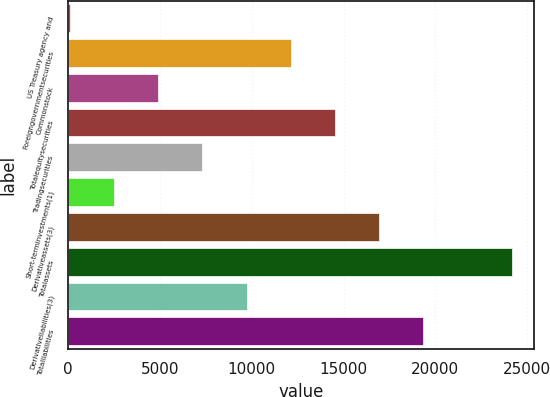Convert chart to OTSL. <chart><loc_0><loc_0><loc_500><loc_500><bar_chart><fcel>US Treasury agency and<fcel>Foreigngovernmentsecurities<fcel>Commonstock<fcel>Totalequitysecurities<fcel>Tradingsecurities<fcel>Short-terminvestments(1)<fcel>Derivativeassets(3)<fcel>Totalassets<fcel>Derivativeliabilities(3)<fcel>Totalliabilities<nl><fcel>88<fcel>12124.5<fcel>4902.6<fcel>14531.8<fcel>7309.9<fcel>2495.3<fcel>16939.1<fcel>24161<fcel>9717.2<fcel>19346.4<nl></chart> 